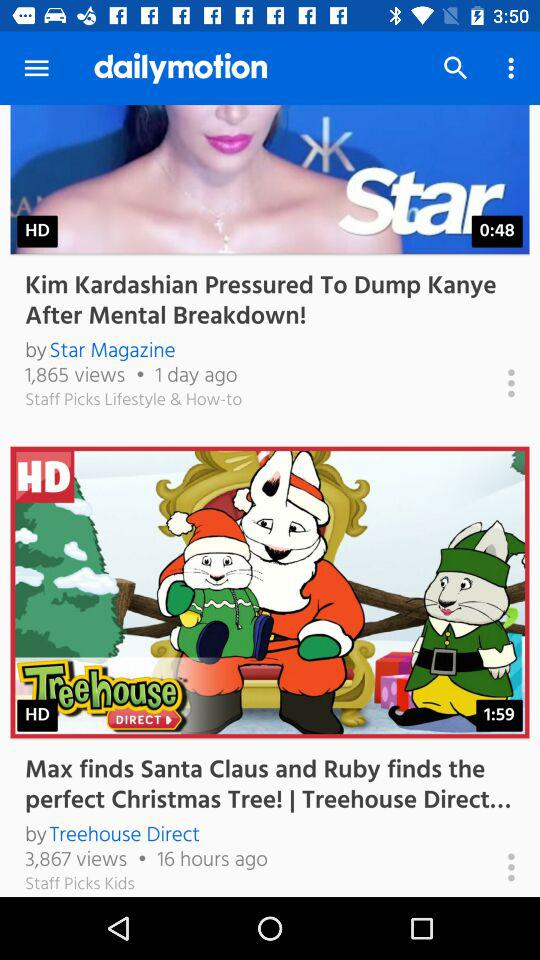How many more views does the video with the most views have than the video with the least views?
Answer the question using a single word or phrase. 2002 